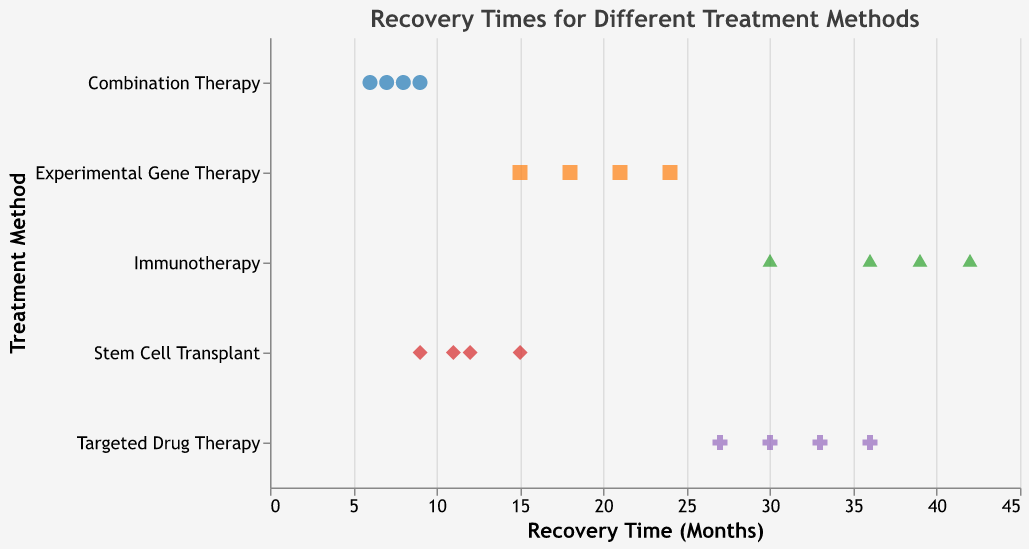What is the title of the figure? The title of the figure is often displayed prominently at the top. In this case, it is "Recovery Times for Different Treatment Methods".
Answer: Recovery Times for Different Treatment Methods Which treatment method has the fewest recovery time data points? To find this, we count the number of data points for each treatment method. "Combination Therapy" has 4 data points, a quick look shows that no other treatment method has fewer data points.
Answer: Combination Therapy What is the range of recovery times for Experimental Gene Therapy? Look at the range on the x-axis for the data points related to Experimental Gene Therapy. The lowest recovery time is 15 months, and the highest is 24 months. The range is from 15 to 24 months.
Answer: 15 to 24 months Which treatment method has the longest recorded recovery time? By examining the x-axis values, we can see that Immunotherapy has the highest recovery time recorded at 42 months.
Answer: Immunotherapy How many treatment methods have at least one recovery time below 10 months? We observe the x-axis for each treatment method and check which have points below 10 months. Only "Stem Cell Transplant" and "Combination Therapy" have values below 10.
Answer: 2 Which treatment method shows the most variability in recovery times? Observing the spread of points on the x-axis for each treatment, Immunotherapy shows a wider spread from 30 to 42 months, indicating the highest variability.
Answer: Immunotherapy What treatment method has all its data points showing recovery times below 10 months? Observing all the data points for each treatment, only Combination Therapy has all its values below 10 months.
Answer: Combination Therapy What is the average recovery time for Targeted Drug Therapy? The recovery times for Targeted Drug Therapy are 27, 33, 30, and 36 months. The sum is 126, and the average is 126/4 = 31.5 months.
Answer: 31.5 months How many data points are plotted for Stem Cell Transplant? By counting the number of points for Stem Cell Transplant, we see there are 4 data points.
Answer: 4 Which treatment method has the smallest median recovery time? The median requires listing all recovery times for each treatment method and finding the middle value. For Experimental Gene Therapy (15, 18, 21, 24: median 19.5), Immunotherapy (30, 36, 39, 42: median 37.5), Stem Cell Transplant (9, 11, 12, 15: median 11.5), Targeted Drug Therapy (27, 30, 33, 36: median 31.5), Combination Therapy (6, 7, 8, 9: median 7.5). Therefore, the smallest median is 7.5 months for Combination Therapy.
Answer: Combination Therapy 